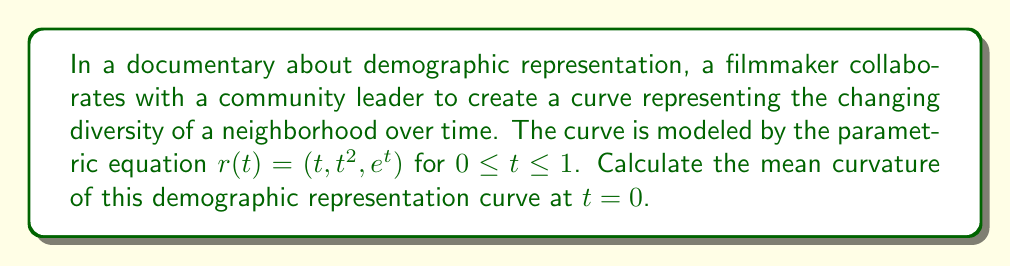Could you help me with this problem? To compute the mean curvature of the given curve, we'll follow these steps:

1) The mean curvature $H$ for a space curve is given by:

   $$H = \frac{\kappa}{2}$$

   where $\kappa$ is the curvature of the curve.

2) For a parametric curve $r(t) = (x(t), y(t), z(t))$, the curvature is given by:

   $$\kappa = \frac{|\dot{r} \times \ddot{r}|}{|\dot{r}|^3}$$

3) Let's calculate $\dot{r}$ and $\ddot{r}$:
   
   $\dot{r} = (1, 2t, e^t)$
   $\ddot{r} = (0, 2, e^t)$

4) At $t = 0$:
   
   $\dot{r}(0) = (1, 0, 1)$
   $\ddot{r}(0) = (0, 2, 1)$

5) Now, let's calculate $\dot{r} \times \ddot{r}$ at $t = 0$:

   $$\dot{r}(0) \times \ddot{r}(0) = \begin{vmatrix}
   i & j & k \\
   1 & 0 & 1 \\
   0 & 2 & 1
   \end{vmatrix} = (2, -1, 2)$$

6) The magnitude of this cross product is:

   $$|\dot{r}(0) \times \ddot{r}(0)| = \sqrt{2^2 + (-1)^2 + 2^2} = 3$$

7) The magnitude of $\dot{r}(0)$ is:

   $$|\dot{r}(0)| = \sqrt{1^2 + 0^2 + 1^2} = \sqrt{2}$$

8) Now we can calculate the curvature at $t = 0$:

   $$\kappa(0) = \frac{|\dot{r}(0) \times \ddot{r}(0)|}{|\dot{r}(0)|^3} = \frac{3}{(\sqrt{2})^3} = \frac{3}{2\sqrt{2}}$$

9) Finally, the mean curvature at $t = 0$ is:

   $$H(0) = \frac{\kappa(0)}{2} = \frac{3}{4\sqrt{2}}$$
Answer: $\frac{3}{4\sqrt{2}}$ 